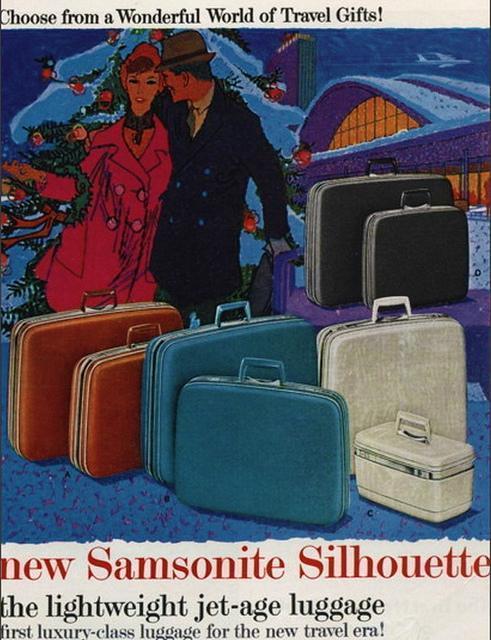How many sets of suitcases are there?
Give a very brief answer. 4. How many bags are shown?
Give a very brief answer. 8. How many suitcases can you see?
Give a very brief answer. 8. How many people can be seen?
Give a very brief answer. 2. 